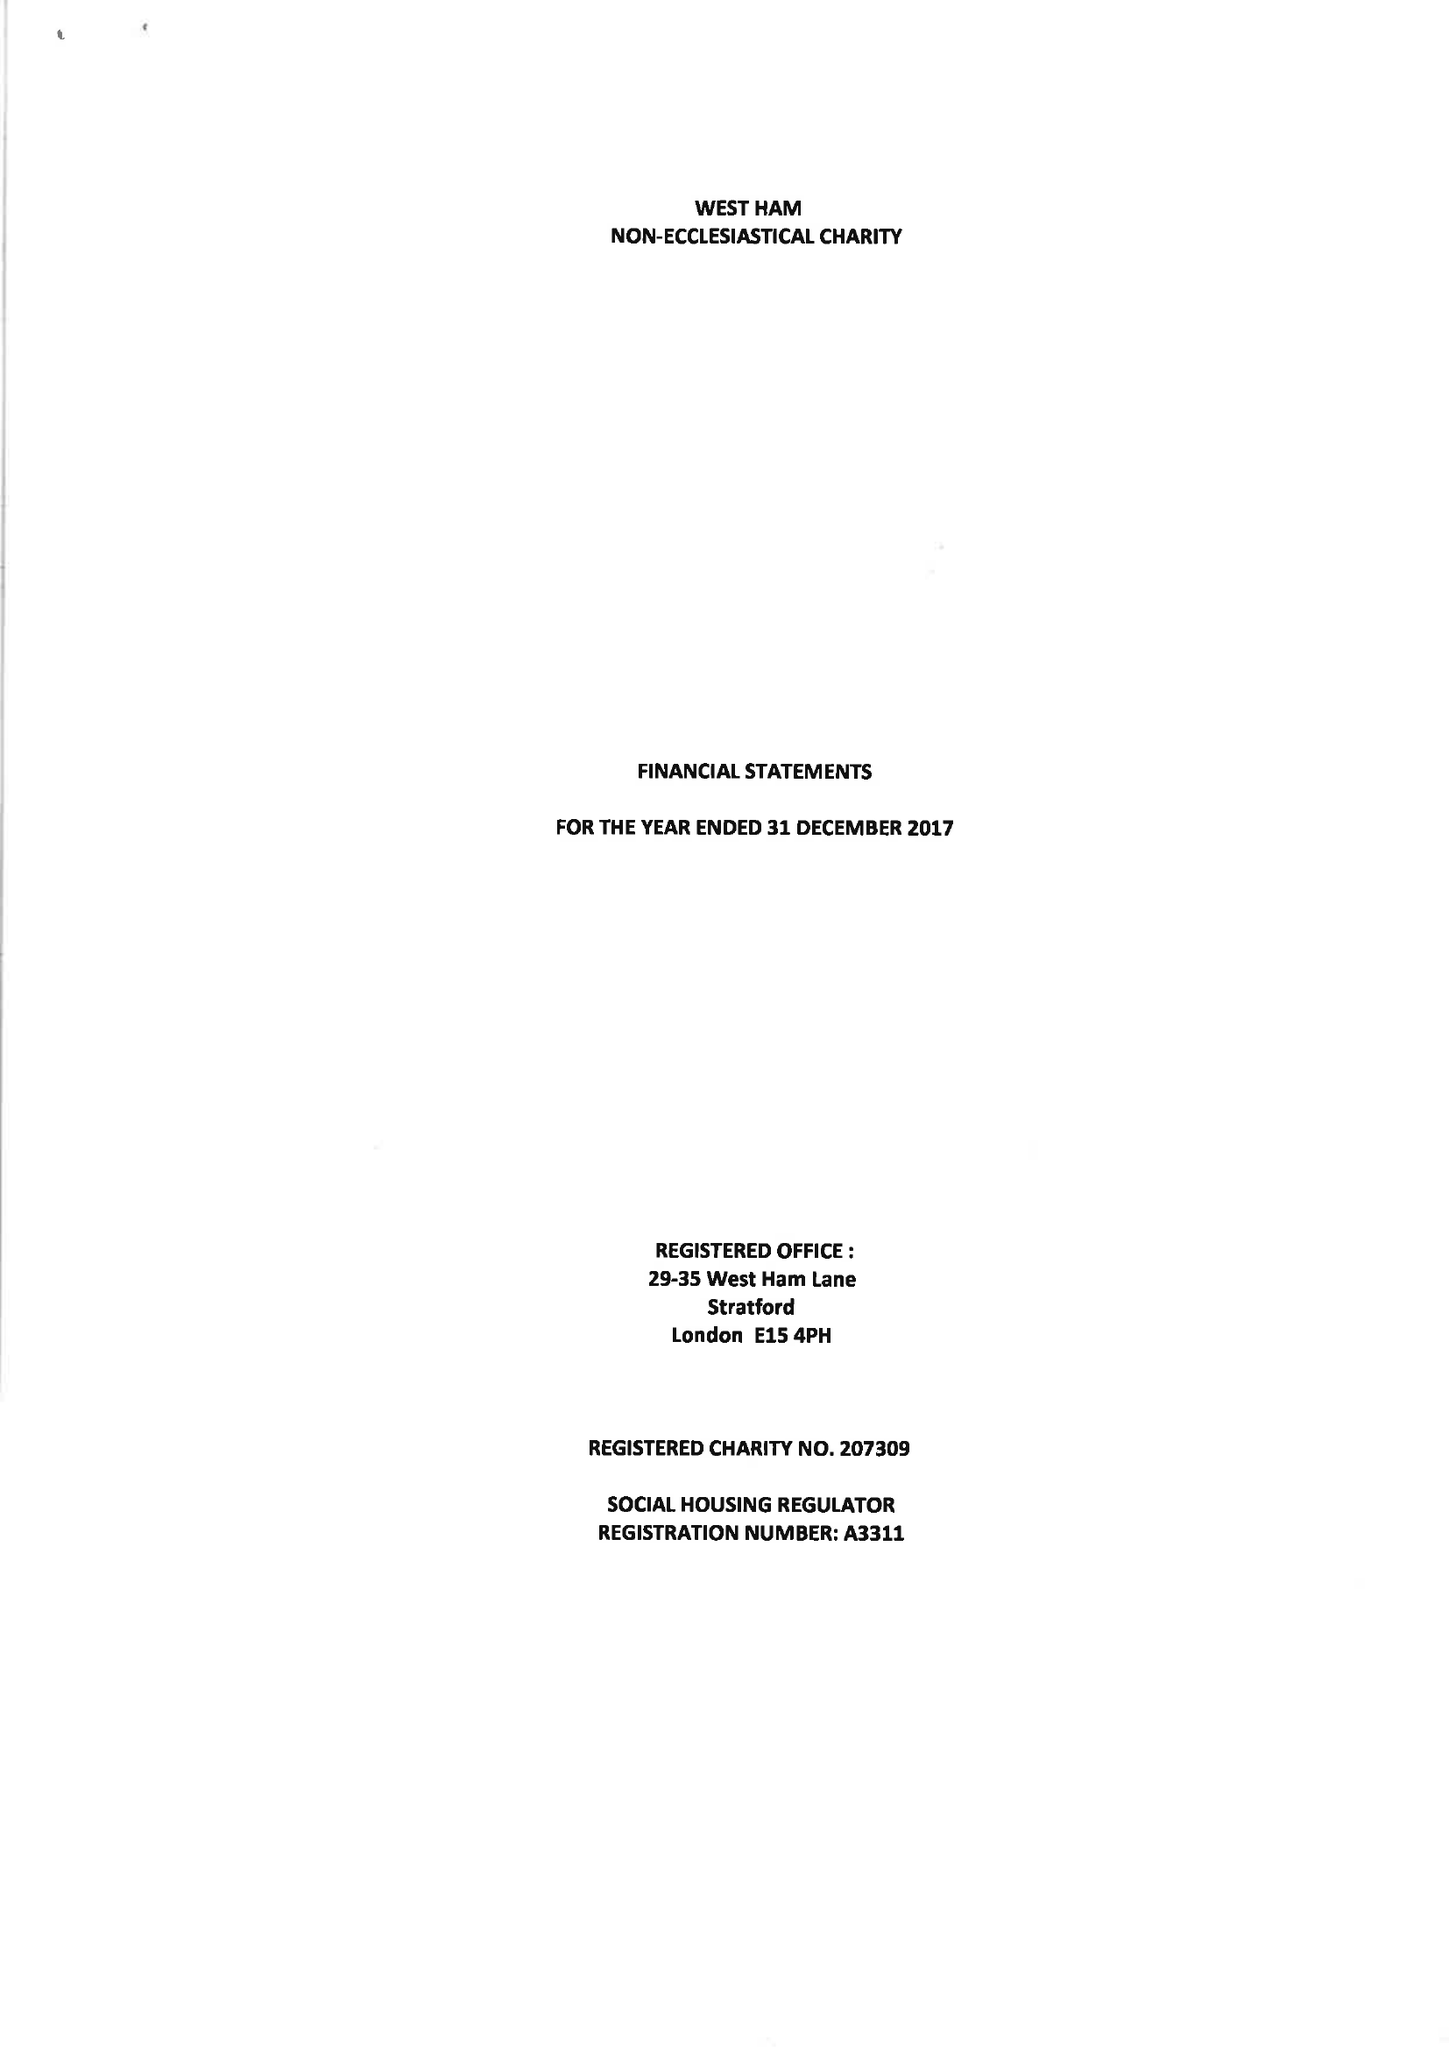What is the value for the spending_annually_in_british_pounds?
Answer the question using a single word or phrase. 59610.00 